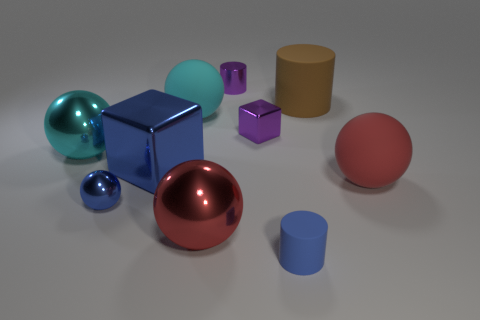Do the tiny object behind the large cylinder and the small block have the same color?
Offer a very short reply. Yes. There is a cylinder that is both behind the big red rubber object and right of the tiny block; what material is it?
Provide a short and direct response. Rubber. What is the size of the blue cube?
Keep it short and to the point. Large. There is a small rubber object; is it the same color as the metal block that is in front of the small purple block?
Offer a terse response. Yes. What number of other objects are there of the same color as the big matte cylinder?
Ensure brevity in your answer.  0. There is a object to the left of the small ball; does it have the same size as the matte thing left of the big red metal thing?
Your answer should be compact. Yes. What color is the rubber cylinder that is in front of the cyan matte object?
Ensure brevity in your answer.  Blue. Are there fewer small purple metal things that are left of the tiny purple cylinder than big blue matte blocks?
Offer a very short reply. No. Is the large blue block made of the same material as the small cube?
Offer a very short reply. Yes. The other cyan thing that is the same shape as the big cyan matte object is what size?
Provide a short and direct response. Large. 